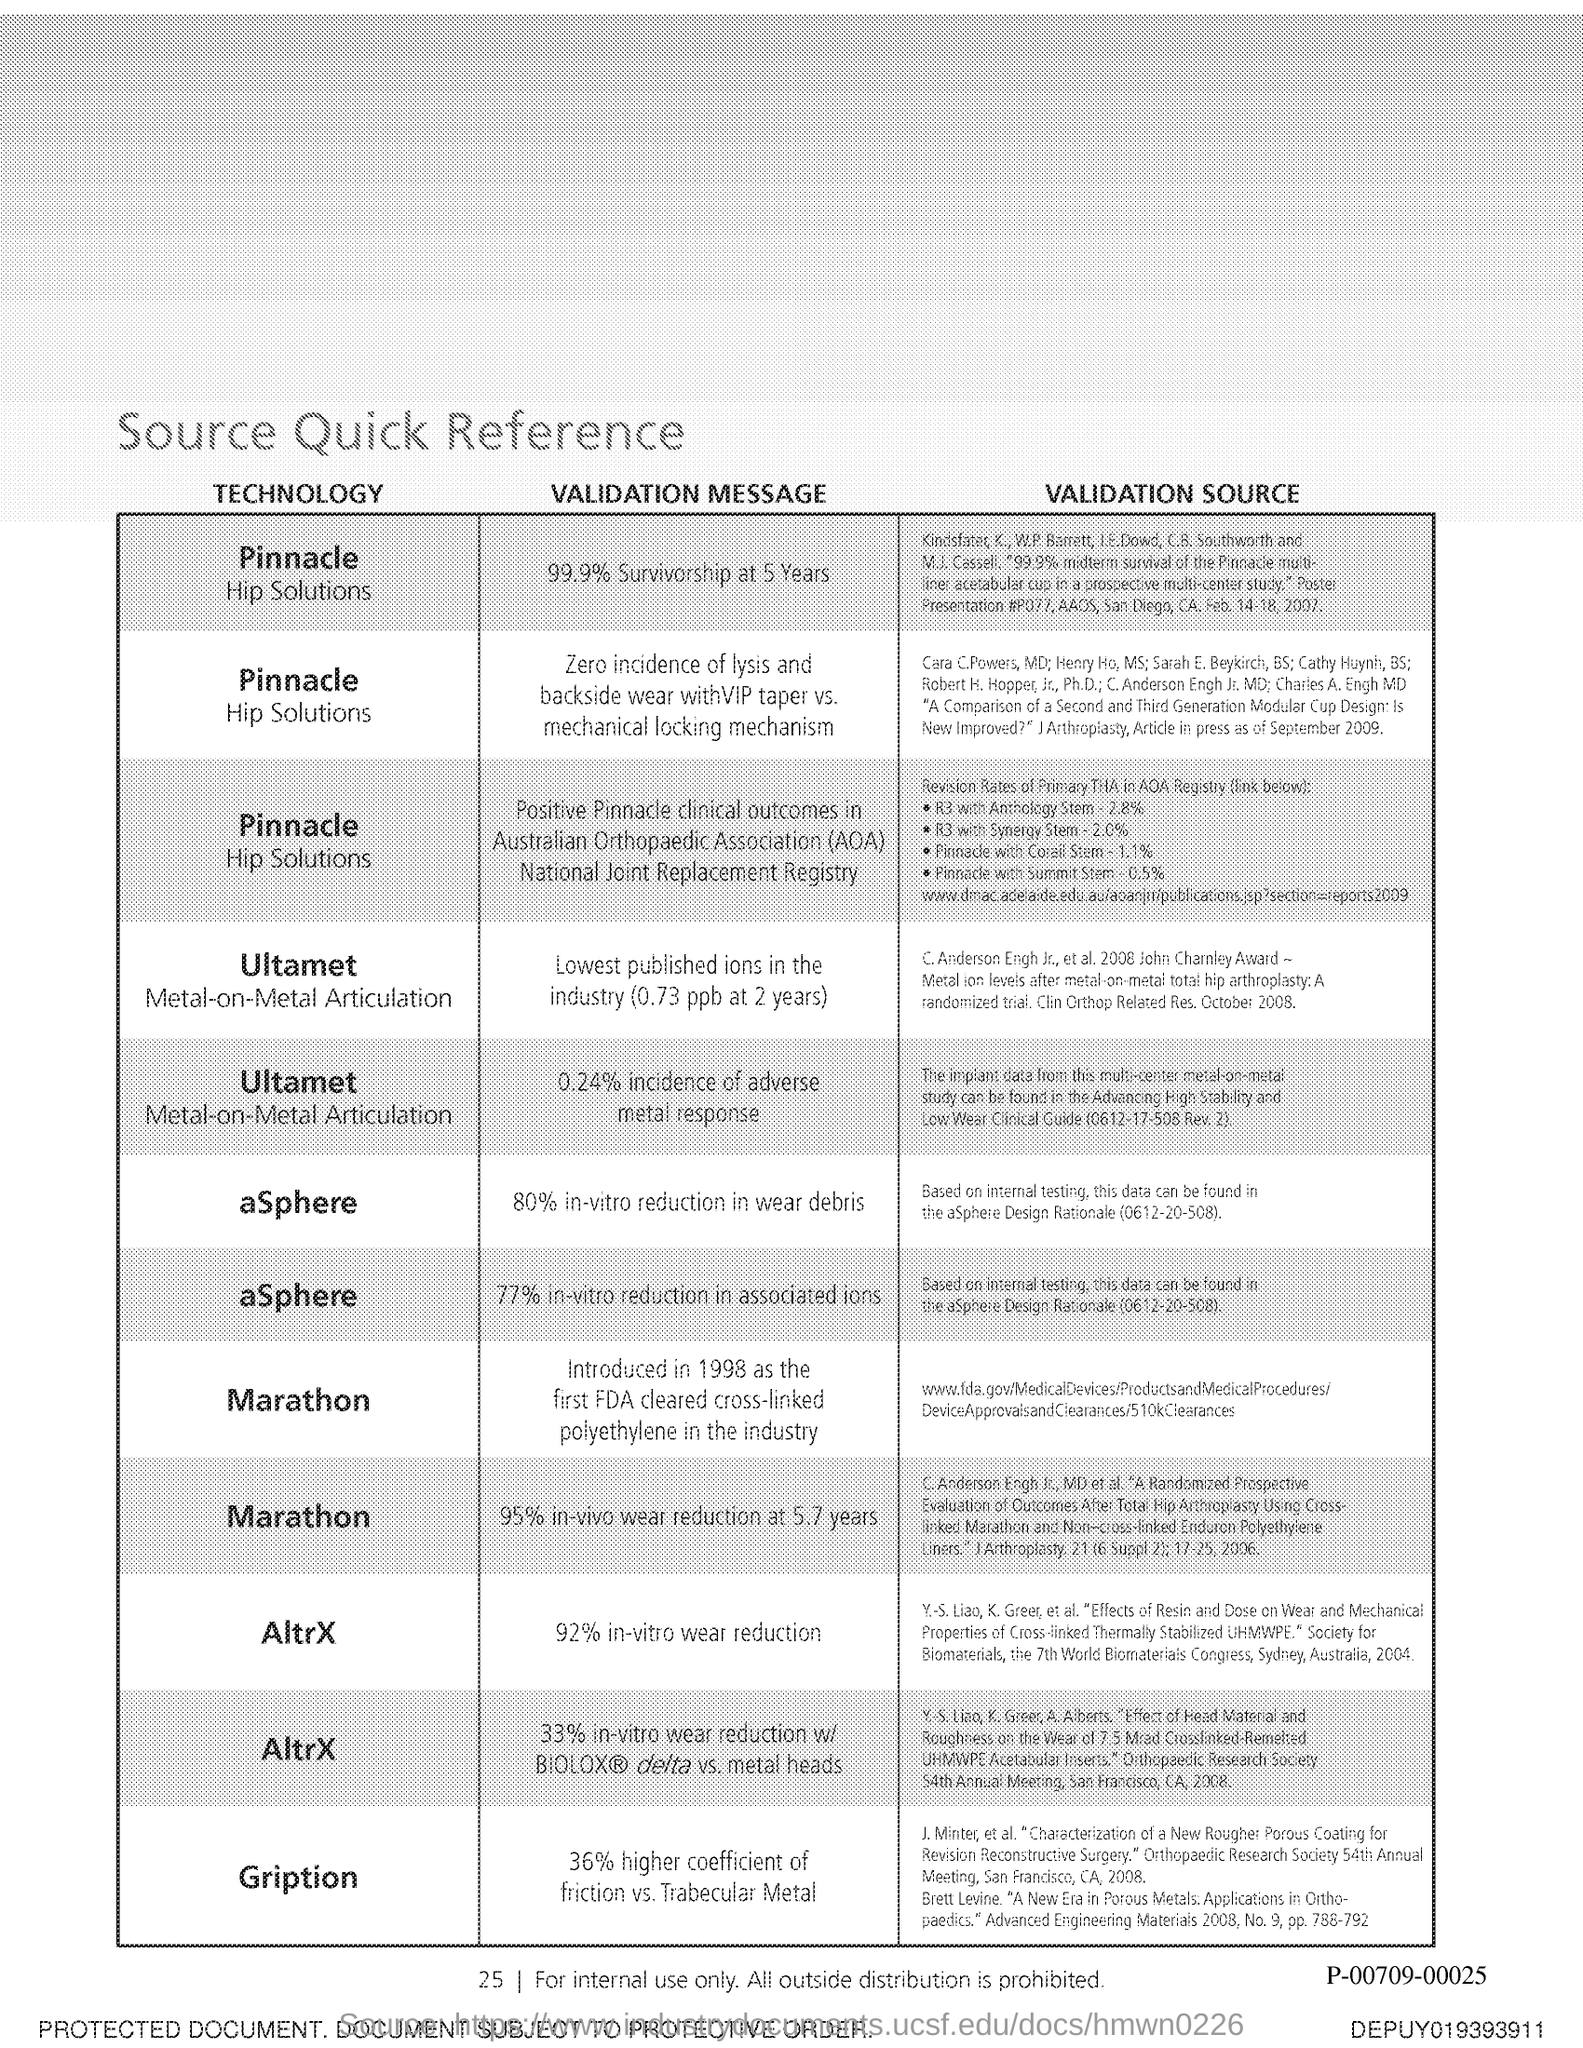What is the validation message of Gription?
Ensure brevity in your answer.  36% higher coefficient of friction vs. Trabecular Metal. 